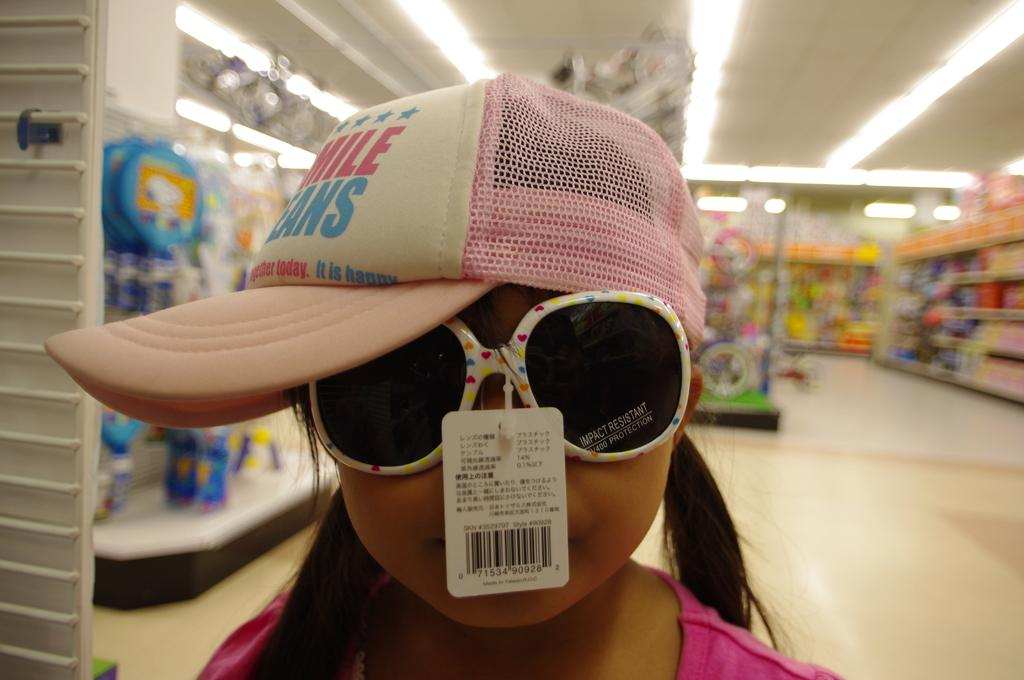Who is the main subject in the image? There is a girl in the image. What is the girl wearing? The girl is wearing a pink dress, spects, and a cap. Can you describe the background of the image? The background of the image is blurred. What type of discussion is taking place between the girl and the boats in the image? There are no boats present in the image, and therefore no discussion can be observed. 